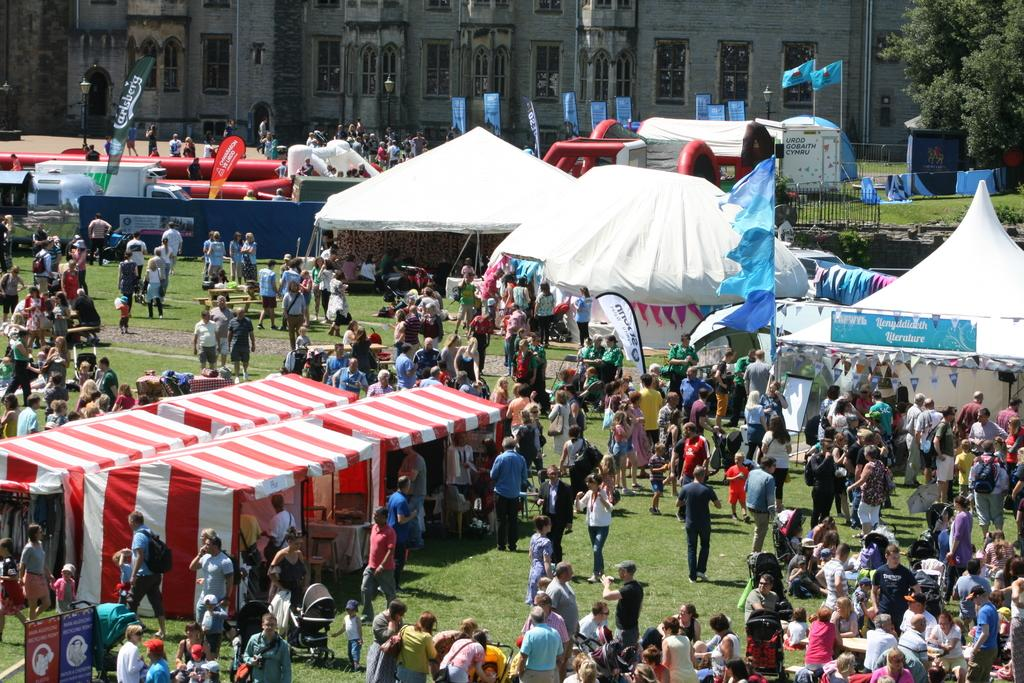What is happening in the image? There are groups of people in the image. Where are the people located in relation to the camps? The people are standing in front of camps. What can be seen in the background of the image? There is a building and trees in the background of the image. What type of prose is being recited by the parent in the image? There is no parent or prose present in the image. What color is the flag flying above the building in the image? There is no flag visible in the image. 